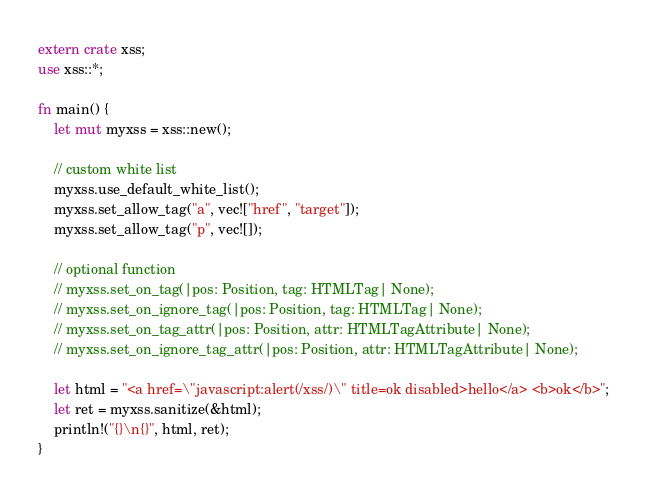<code> <loc_0><loc_0><loc_500><loc_500><_Rust_>extern crate xss;
use xss::*;

fn main() {
    let mut myxss = xss::new();

    // custom white list
    myxss.use_default_white_list();
    myxss.set_allow_tag("a", vec!["href", "target"]);
    myxss.set_allow_tag("p", vec![]);

    // optional function
    // myxss.set_on_tag(|pos: Position, tag: HTMLTag| None);
    // myxss.set_on_ignore_tag(|pos: Position, tag: HTMLTag| None);
    // myxss.set_on_tag_attr(|pos: Position, attr: HTMLTagAttribute| None);
    // myxss.set_on_ignore_tag_attr(|pos: Position, attr: HTMLTagAttribute| None);

    let html = "<a href=\"javascript:alert(/xss/)\" title=ok disabled>hello</a> <b>ok</b>";
    let ret = myxss.sanitize(&html);
    println!("{}\n{}", html, ret);
}
</code> 